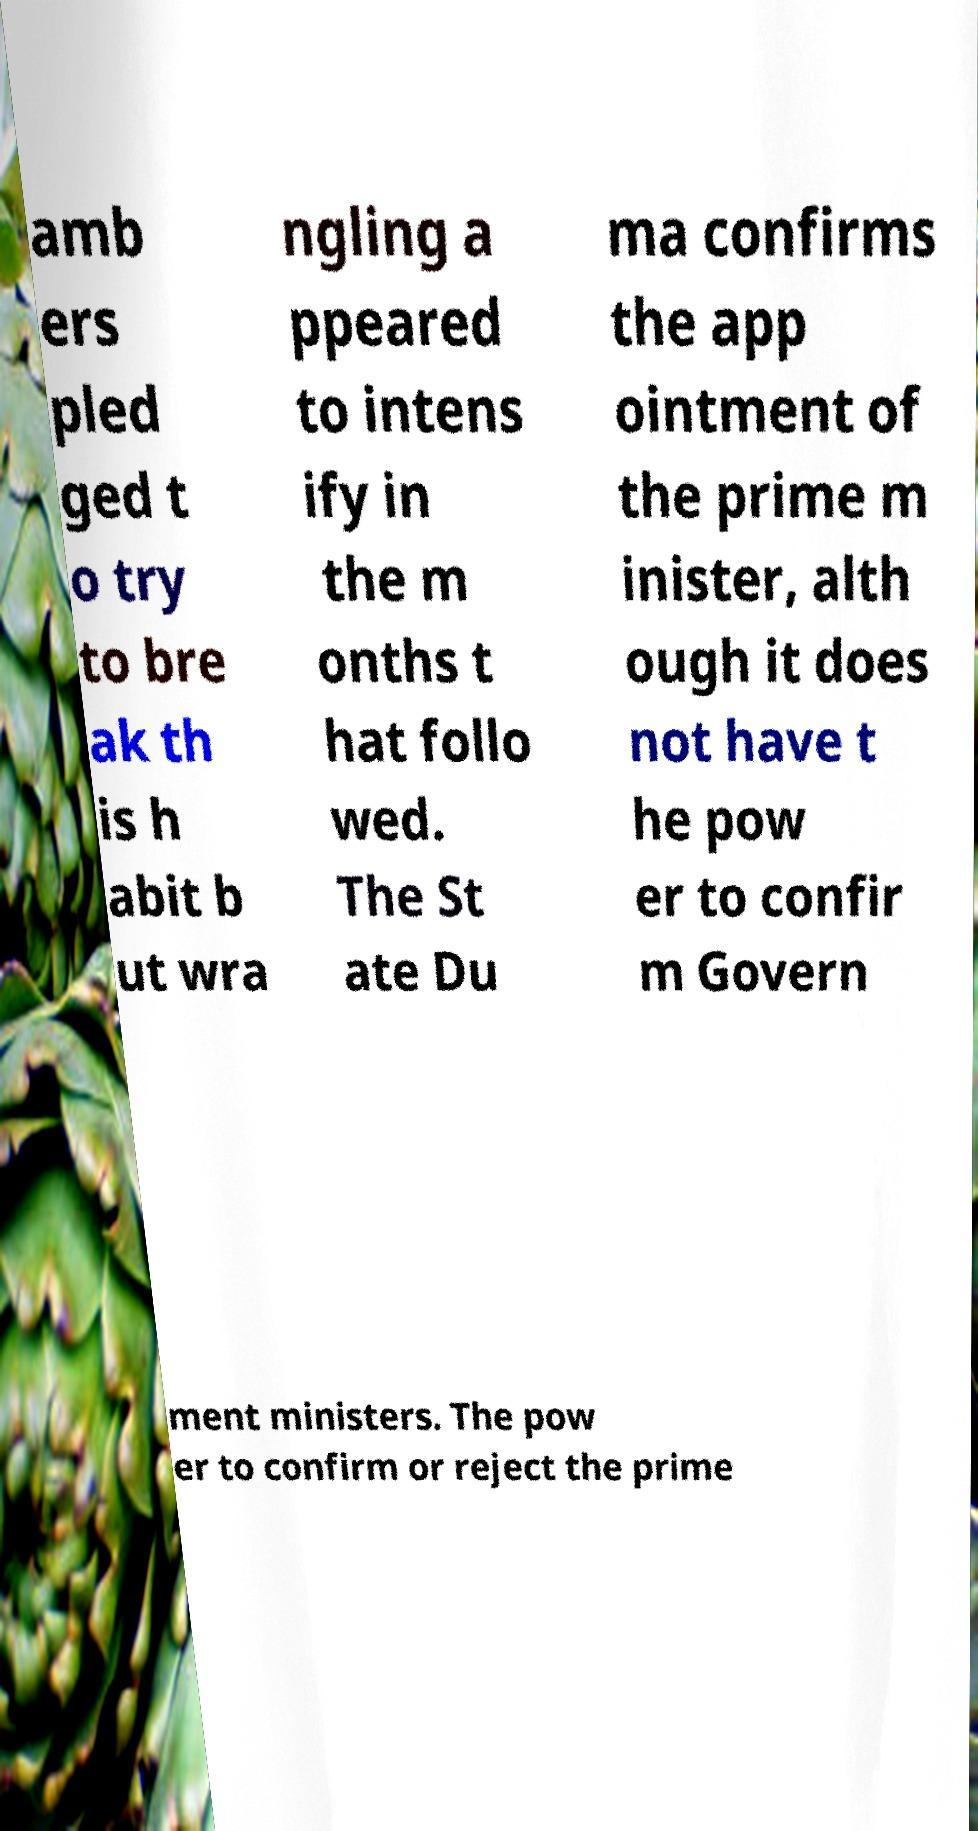Please read and relay the text visible in this image. What does it say? amb ers pled ged t o try to bre ak th is h abit b ut wra ngling a ppeared to intens ify in the m onths t hat follo wed. The St ate Du ma confirms the app ointment of the prime m inister, alth ough it does not have t he pow er to confir m Govern ment ministers. The pow er to confirm or reject the prime 